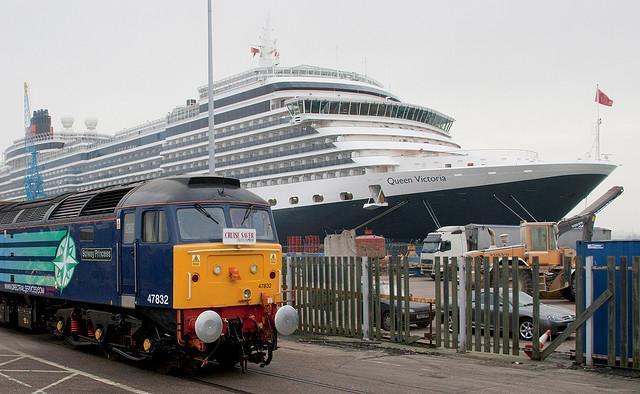Does the caption "The boat is parallel to the truck." correctly depict the image?
Answer yes or no. No. 